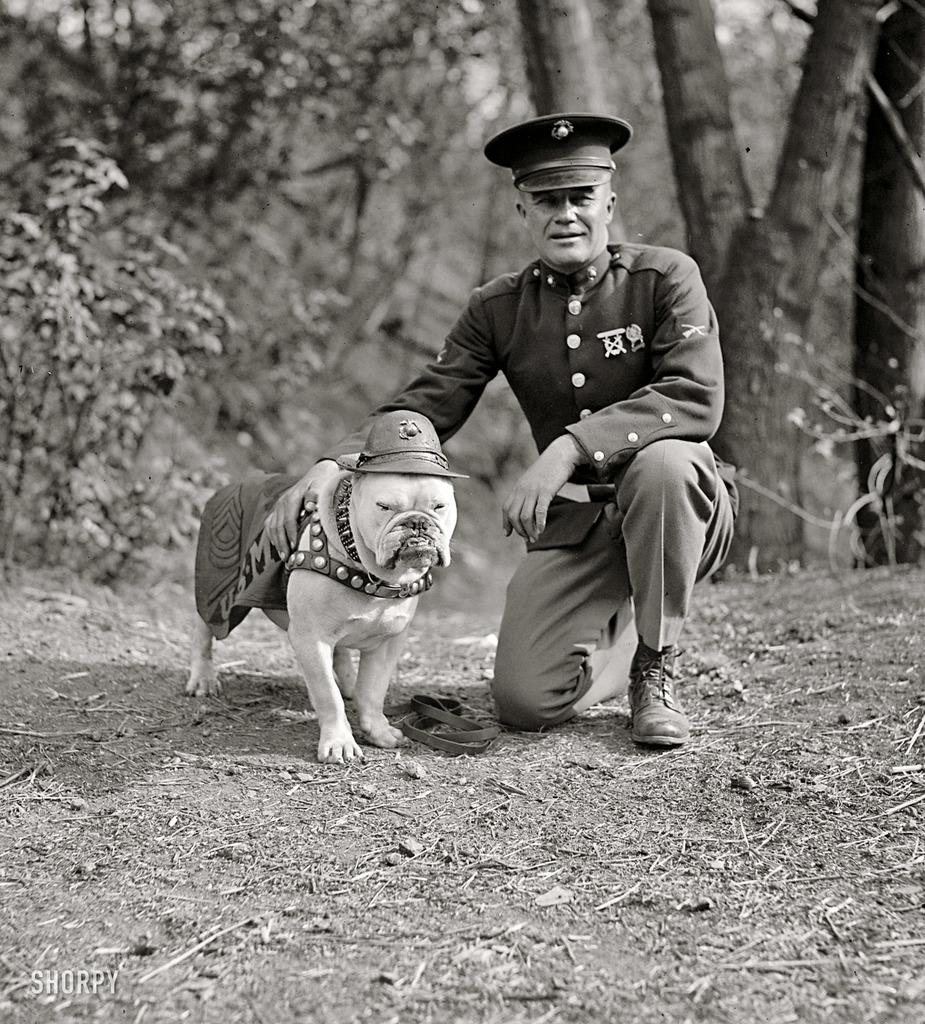What is the man doing in the image? The man is sitting on his knee in the middle of the image. What is beside the man? There is a dog beside the man. What is unique about the dog's appearance? The dog is wearing a hat. What can be seen in the background of the image? There are trees in the background of the image. What type of game is the man offering to the dog in the image? There is no game being offered in the image; the man is simply sitting on his knee with a dog beside him. 